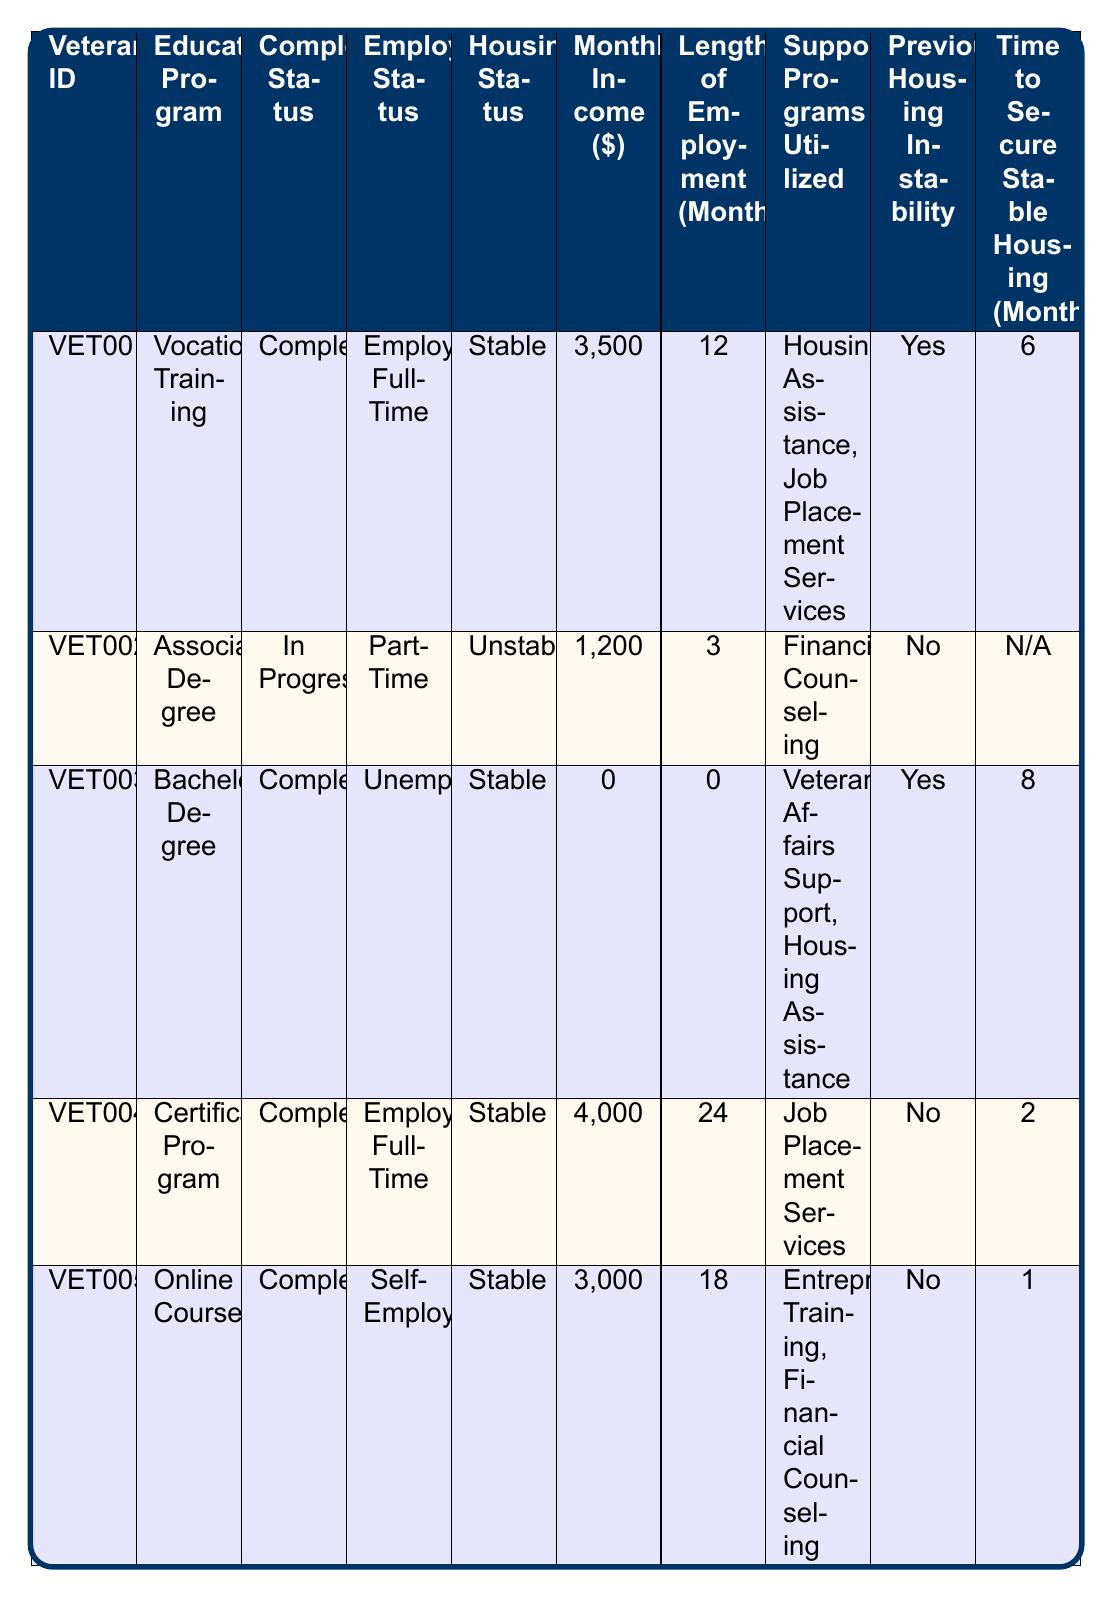What is the monthly income of the veteran enrolled in the Associate Degree program? The table lists the veteran with ID VET002, who is enrolled in the Associate Degree program. The corresponding monthly income listed for this veteran is $1,200.
Answer: $1,200 How many veterans have completed their educational programs? By examining the completion status column, we see that veterans VET001, VET003, VET004, and VET005 have all completed their programs. There are 4 out of 5 records that show "Completed."
Answer: 4 What is the average monthly income of the veterans with stable housing? The veterans with stable housing (VET001, VET003, VET004, and VET005) have monthly incomes of $3,500, $0, $4,000, and $3,000, respectively. We calculate the average: (3500 + 0 + 4000 + 3000) / 4 = 2625.
Answer: $2,625 Is there any veteran currently unemployed? Looking at the employment status column, veteran VET003 is listed as "Unemployed." Therefore, the answer is yes.
Answer: Yes Which program had the highest income among the veterans? We compare the monthly incomes of all veterans: VET001 ($3,500), VET002 ($1,200), VET003 ($0), VET004 ($4,000), and VET005 ($3,000). The highest income is $4,000 for VET004 in the Certificate Program.
Answer: $4,000 How many veterans utilized more than one support program? By reviewing the support programs utilized, we observe that veterans VET001 and VET005 utilized two programs each. Thus, there are 2 veterans who utilized more than one support program.
Answer: 2 What is the difference in monthly income between the veteran with the highest income and the veteran with the lowest income? The highest monthly income is $4,000 (VET004) and the lowest is $0 (VET003). The difference is $4,000 - $0 = $4,000.
Answer: $4,000 What was the time taken to secure stable housing for the veteran with the longest employment? The veteran VET004 is employed for 24 months. Referring to the time to secure stable housing, we see that this veteran took 2 months to secure stable housing.
Answer: 2 months Is there any correlation between completion status and employment status based on this data? By analyzing the table, we link completion status to employment status: all completed veterans are either employed or self-employed, while the in-progress veteran is part-time. This shows that completion may lead to better employment outcomes.
Answer: Yes How many veterans reported previous housing instability? By checking the previous housing instability column, we see that 3 veterans (VET001, VET003) indicated "Yes," while 2 veterans (VET002, VET004, VET005) indicated "No." Therefore, the answer is 2 veterans experienced previous housing instability.
Answer: 2 